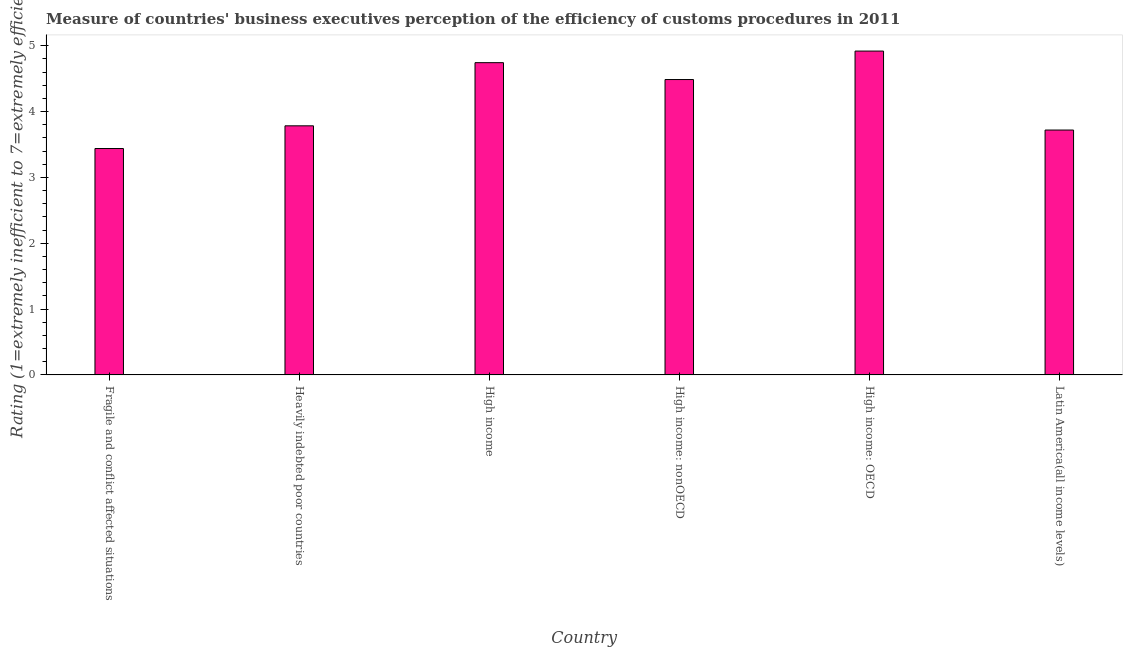Does the graph contain grids?
Offer a terse response. No. What is the title of the graph?
Provide a succinct answer. Measure of countries' business executives perception of the efficiency of customs procedures in 2011. What is the label or title of the X-axis?
Give a very brief answer. Country. What is the label or title of the Y-axis?
Offer a terse response. Rating (1=extremely inefficient to 7=extremely efficient). What is the rating measuring burden of customs procedure in High income: OECD?
Keep it short and to the point. 4.92. Across all countries, what is the maximum rating measuring burden of customs procedure?
Your answer should be compact. 4.92. Across all countries, what is the minimum rating measuring burden of customs procedure?
Give a very brief answer. 3.44. In which country was the rating measuring burden of customs procedure maximum?
Keep it short and to the point. High income: OECD. In which country was the rating measuring burden of customs procedure minimum?
Offer a very short reply. Fragile and conflict affected situations. What is the sum of the rating measuring burden of customs procedure?
Make the answer very short. 25.09. What is the difference between the rating measuring burden of customs procedure in High income and Latin America(all income levels)?
Keep it short and to the point. 1.02. What is the average rating measuring burden of customs procedure per country?
Ensure brevity in your answer.  4.18. What is the median rating measuring burden of customs procedure?
Give a very brief answer. 4.13. What is the ratio of the rating measuring burden of customs procedure in Heavily indebted poor countries to that in High income?
Make the answer very short. 0.8. Is the rating measuring burden of customs procedure in High income: nonOECD less than that in Latin America(all income levels)?
Your response must be concise. No. What is the difference between the highest and the second highest rating measuring burden of customs procedure?
Give a very brief answer. 0.18. What is the difference between the highest and the lowest rating measuring burden of customs procedure?
Ensure brevity in your answer.  1.48. How many bars are there?
Keep it short and to the point. 6. Are all the bars in the graph horizontal?
Give a very brief answer. No. How many countries are there in the graph?
Keep it short and to the point. 6. Are the values on the major ticks of Y-axis written in scientific E-notation?
Give a very brief answer. No. What is the Rating (1=extremely inefficient to 7=extremely efficient) in Fragile and conflict affected situations?
Your answer should be compact. 3.44. What is the Rating (1=extremely inefficient to 7=extremely efficient) in Heavily indebted poor countries?
Offer a very short reply. 3.78. What is the Rating (1=extremely inefficient to 7=extremely efficient) of High income?
Offer a terse response. 4.74. What is the Rating (1=extremely inefficient to 7=extremely efficient) of High income: nonOECD?
Your answer should be compact. 4.49. What is the Rating (1=extremely inefficient to 7=extremely efficient) of High income: OECD?
Ensure brevity in your answer.  4.92. What is the Rating (1=extremely inefficient to 7=extremely efficient) in Latin America(all income levels)?
Your answer should be very brief. 3.72. What is the difference between the Rating (1=extremely inefficient to 7=extremely efficient) in Fragile and conflict affected situations and Heavily indebted poor countries?
Offer a terse response. -0.34. What is the difference between the Rating (1=extremely inefficient to 7=extremely efficient) in Fragile and conflict affected situations and High income?
Offer a very short reply. -1.3. What is the difference between the Rating (1=extremely inefficient to 7=extremely efficient) in Fragile and conflict affected situations and High income: nonOECD?
Provide a succinct answer. -1.05. What is the difference between the Rating (1=extremely inefficient to 7=extremely efficient) in Fragile and conflict affected situations and High income: OECD?
Offer a very short reply. -1.48. What is the difference between the Rating (1=extremely inefficient to 7=extremely efficient) in Fragile and conflict affected situations and Latin America(all income levels)?
Provide a succinct answer. -0.28. What is the difference between the Rating (1=extremely inefficient to 7=extremely efficient) in Heavily indebted poor countries and High income?
Your response must be concise. -0.96. What is the difference between the Rating (1=extremely inefficient to 7=extremely efficient) in Heavily indebted poor countries and High income: nonOECD?
Your answer should be very brief. -0.7. What is the difference between the Rating (1=extremely inefficient to 7=extremely efficient) in Heavily indebted poor countries and High income: OECD?
Make the answer very short. -1.14. What is the difference between the Rating (1=extremely inefficient to 7=extremely efficient) in Heavily indebted poor countries and Latin America(all income levels)?
Ensure brevity in your answer.  0.06. What is the difference between the Rating (1=extremely inefficient to 7=extremely efficient) in High income and High income: nonOECD?
Your answer should be very brief. 0.26. What is the difference between the Rating (1=extremely inefficient to 7=extremely efficient) in High income and High income: OECD?
Keep it short and to the point. -0.18. What is the difference between the Rating (1=extremely inefficient to 7=extremely efficient) in High income and Latin America(all income levels)?
Your answer should be compact. 1.02. What is the difference between the Rating (1=extremely inefficient to 7=extremely efficient) in High income: nonOECD and High income: OECD?
Keep it short and to the point. -0.43. What is the difference between the Rating (1=extremely inefficient to 7=extremely efficient) in High income: nonOECD and Latin America(all income levels)?
Give a very brief answer. 0.77. What is the difference between the Rating (1=extremely inefficient to 7=extremely efficient) in High income: OECD and Latin America(all income levels)?
Offer a very short reply. 1.2. What is the ratio of the Rating (1=extremely inefficient to 7=extremely efficient) in Fragile and conflict affected situations to that in Heavily indebted poor countries?
Your response must be concise. 0.91. What is the ratio of the Rating (1=extremely inefficient to 7=extremely efficient) in Fragile and conflict affected situations to that in High income?
Ensure brevity in your answer.  0.72. What is the ratio of the Rating (1=extremely inefficient to 7=extremely efficient) in Fragile and conflict affected situations to that in High income: nonOECD?
Keep it short and to the point. 0.77. What is the ratio of the Rating (1=extremely inefficient to 7=extremely efficient) in Fragile and conflict affected situations to that in High income: OECD?
Keep it short and to the point. 0.7. What is the ratio of the Rating (1=extremely inefficient to 7=extremely efficient) in Fragile and conflict affected situations to that in Latin America(all income levels)?
Your answer should be very brief. 0.93. What is the ratio of the Rating (1=extremely inefficient to 7=extremely efficient) in Heavily indebted poor countries to that in High income?
Offer a terse response. 0.8. What is the ratio of the Rating (1=extremely inefficient to 7=extremely efficient) in Heavily indebted poor countries to that in High income: nonOECD?
Your answer should be very brief. 0.84. What is the ratio of the Rating (1=extremely inefficient to 7=extremely efficient) in Heavily indebted poor countries to that in High income: OECD?
Your response must be concise. 0.77. What is the ratio of the Rating (1=extremely inefficient to 7=extremely efficient) in Heavily indebted poor countries to that in Latin America(all income levels)?
Your response must be concise. 1.02. What is the ratio of the Rating (1=extremely inefficient to 7=extremely efficient) in High income to that in High income: nonOECD?
Ensure brevity in your answer.  1.06. What is the ratio of the Rating (1=extremely inefficient to 7=extremely efficient) in High income to that in High income: OECD?
Keep it short and to the point. 0.96. What is the ratio of the Rating (1=extremely inefficient to 7=extremely efficient) in High income to that in Latin America(all income levels)?
Your answer should be compact. 1.27. What is the ratio of the Rating (1=extremely inefficient to 7=extremely efficient) in High income: nonOECD to that in High income: OECD?
Offer a terse response. 0.91. What is the ratio of the Rating (1=extremely inefficient to 7=extremely efficient) in High income: nonOECD to that in Latin America(all income levels)?
Offer a very short reply. 1.21. What is the ratio of the Rating (1=extremely inefficient to 7=extremely efficient) in High income: OECD to that in Latin America(all income levels)?
Offer a very short reply. 1.32. 